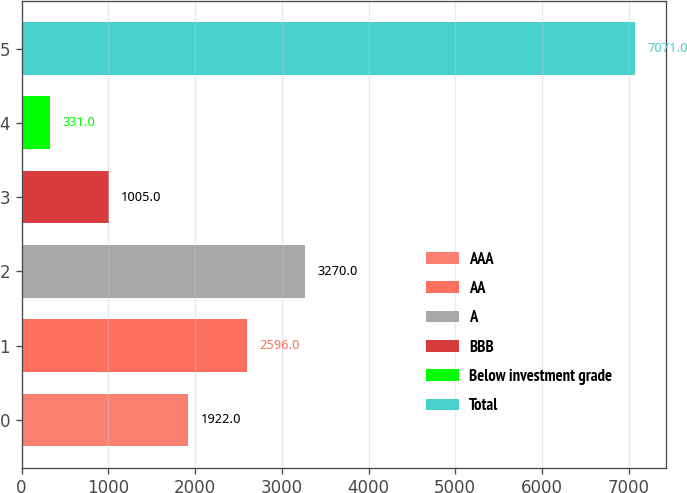Convert chart. <chart><loc_0><loc_0><loc_500><loc_500><bar_chart><fcel>AAA<fcel>AA<fcel>A<fcel>BBB<fcel>Below investment grade<fcel>Total<nl><fcel>1922<fcel>2596<fcel>3270<fcel>1005<fcel>331<fcel>7071<nl></chart> 